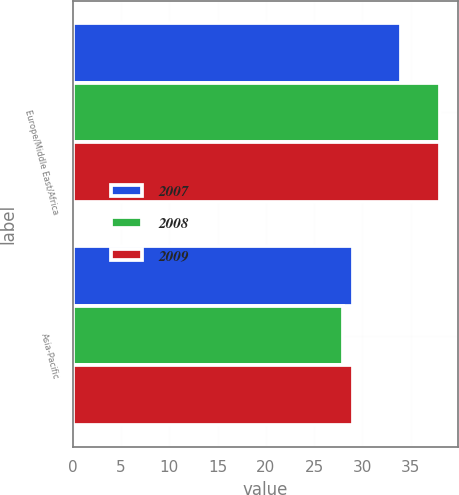<chart> <loc_0><loc_0><loc_500><loc_500><stacked_bar_chart><ecel><fcel>Europe/Middle East/Africa<fcel>Asia-Pacific<nl><fcel>2007<fcel>34<fcel>29<nl><fcel>2008<fcel>38<fcel>28<nl><fcel>2009<fcel>38<fcel>29<nl></chart> 